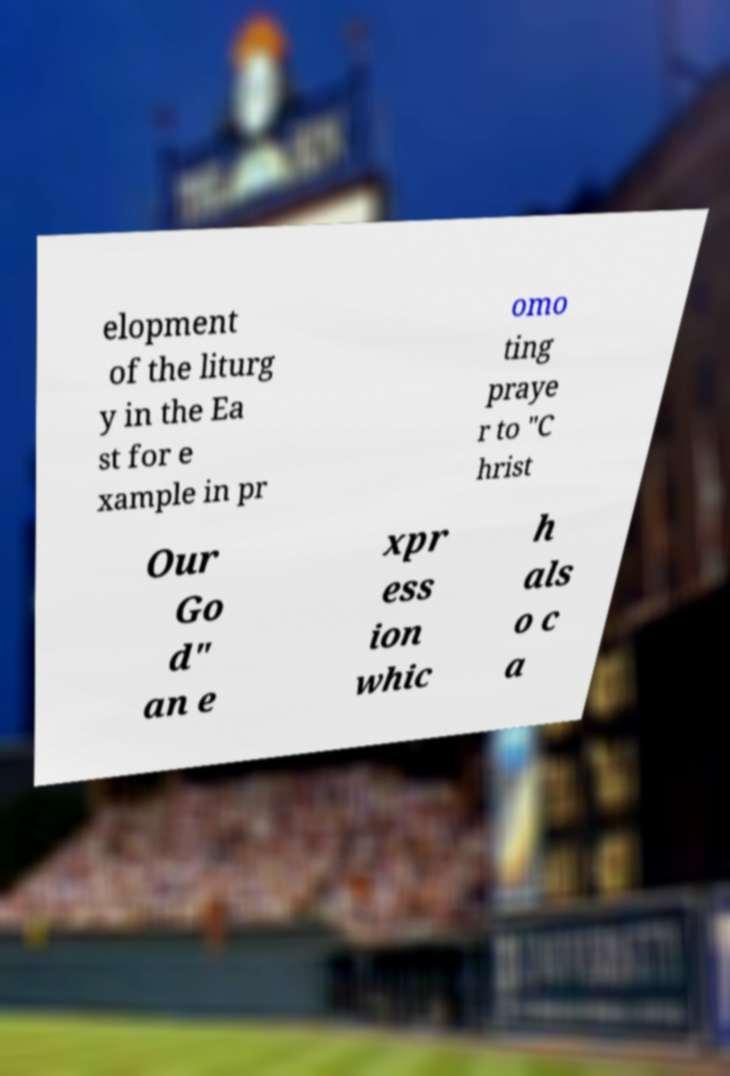Could you assist in decoding the text presented in this image and type it out clearly? elopment of the liturg y in the Ea st for e xample in pr omo ting praye r to "C hrist Our Go d" an e xpr ess ion whic h als o c a 